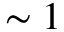<formula> <loc_0><loc_0><loc_500><loc_500>\sim 1</formula> 